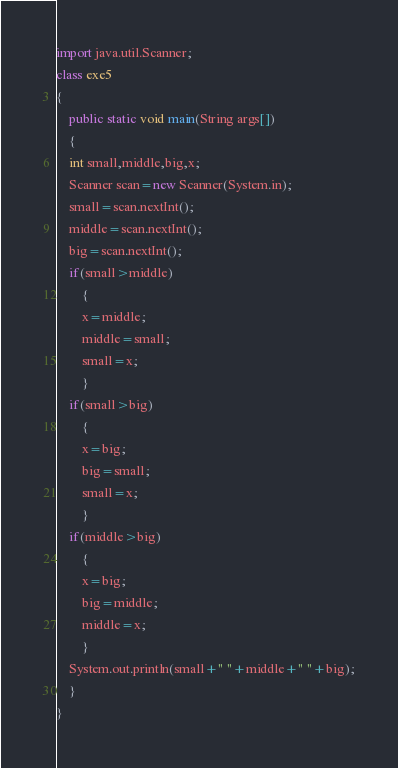<code> <loc_0><loc_0><loc_500><loc_500><_Java_>import java.util.Scanner;
class exe5
{
    public static void main(String args[])
    {
	int small,middle,big,x;
	Scanner scan=new Scanner(System.in);
	small=scan.nextInt();
	middle=scan.nextInt();
	big=scan.nextInt();
	if(small>middle)
	    {
		x=middle;
		middle=small;
		small=x;
	    }
	if(small>big)
	    {
		x=big;
		big=small;
		small=x;
	    }
	if(middle>big)
	    {
		x=big;
		big=middle;
		middle=x;
	    }
	System.out.println(small+" "+middle+" "+big);
    }
}</code> 